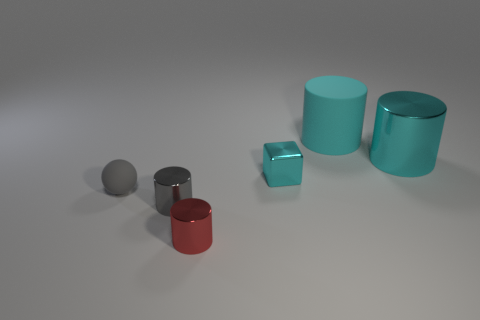What number of small objects are either cyan metal cubes or shiny cylinders? 3 